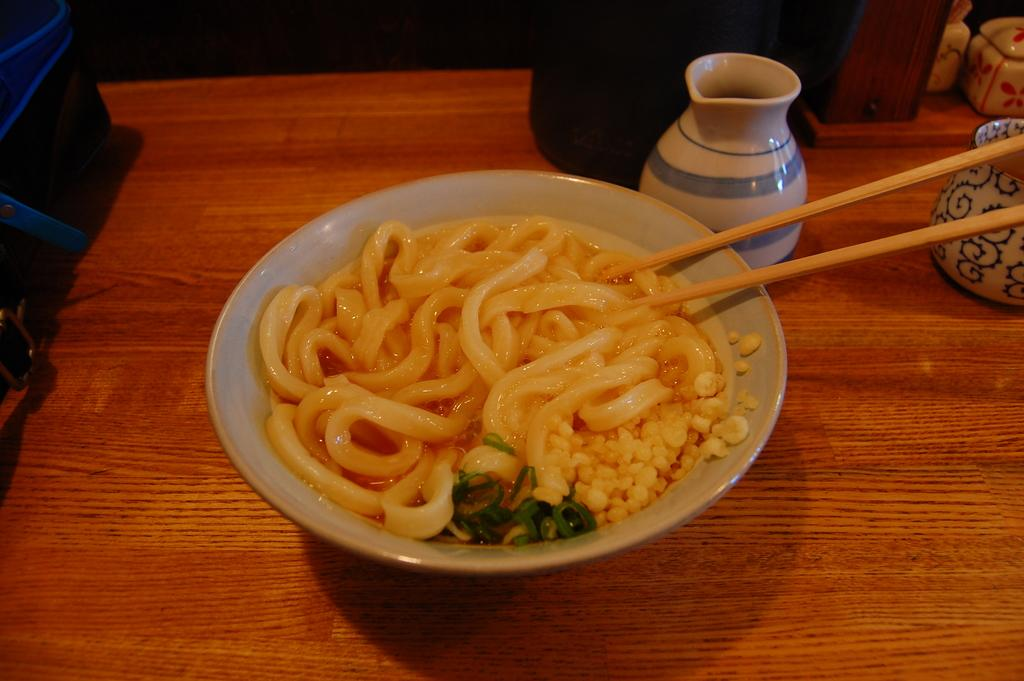What type of furniture is present in the image? There is a table in the image. What is on the table? There is a bowl with food on the table, as well as chopsticks. What else can be seen in the image besides the table and food? There is a pot and another bowl on the table. What type of dirt can be seen in the image? There is no dirt present in the image. What attraction is being depicted in the image? The image does not depict an attraction; it shows a table with various items on it. 